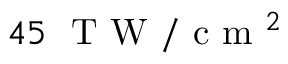Convert formula to latex. <formula><loc_0><loc_0><loc_500><loc_500>4 5 \ T W / c m ^ { 2 }</formula> 